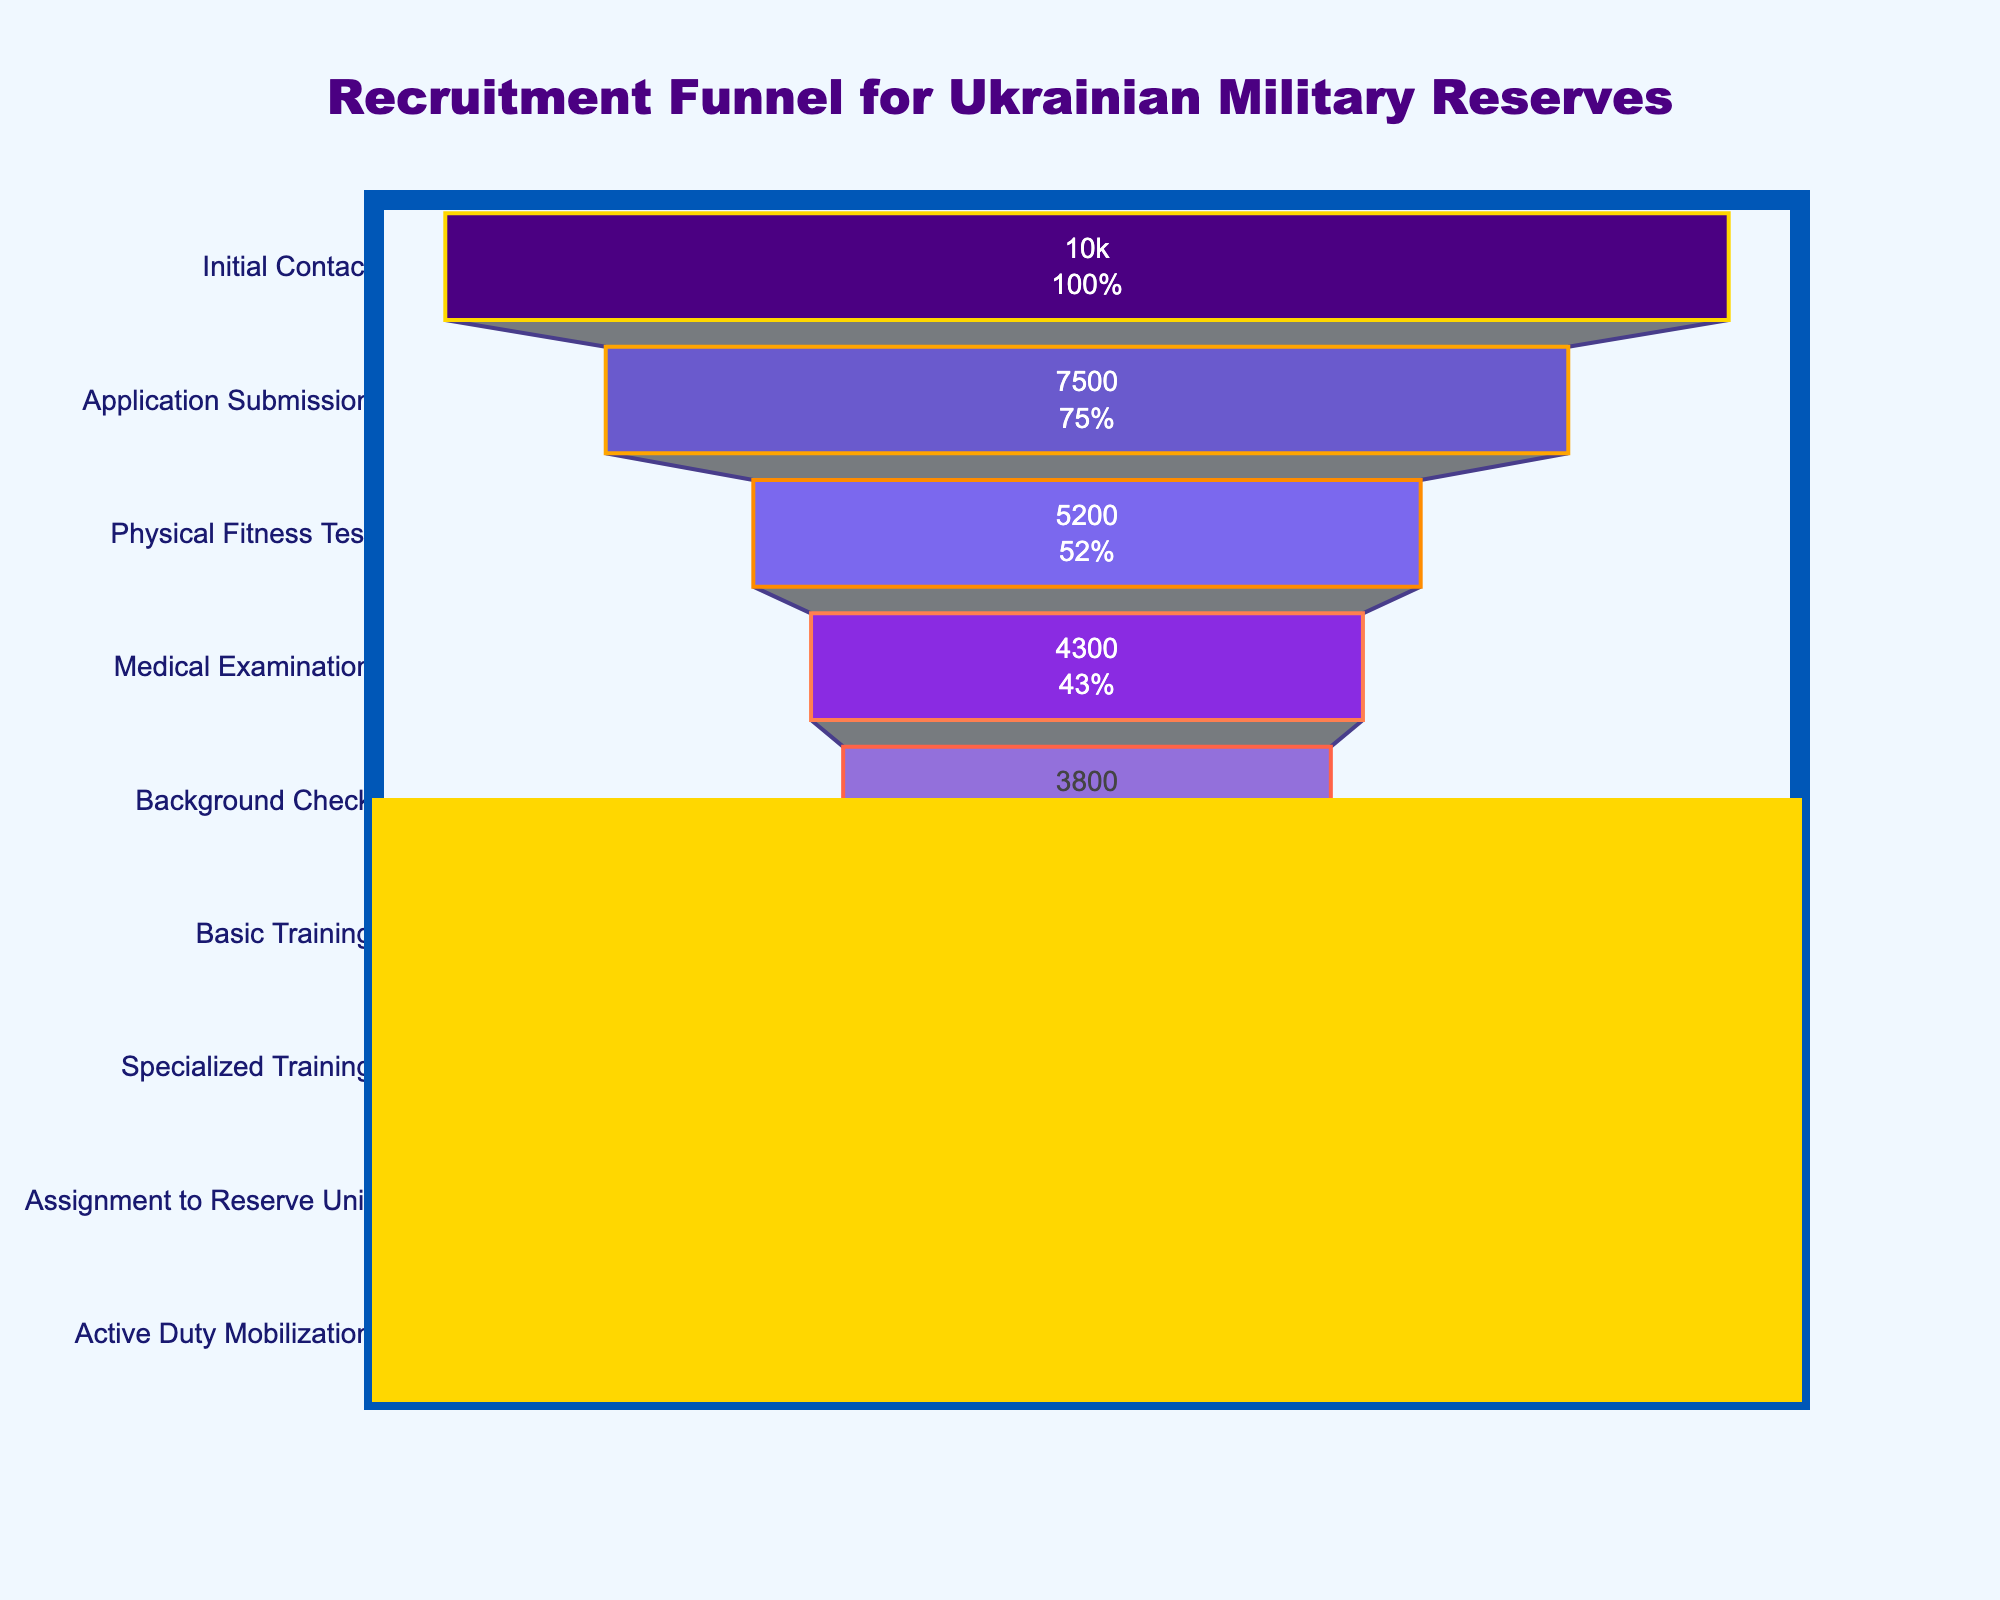How many stages are represented in the recruitment funnel? Count the unique stages listed on the y-axis of the funnel chart: Initial Contact, Application Submission, Physical Fitness Test, Medical Examination, Background Check, Basic Training, Specialized Training, Assignment to Reserve Unit, Active Duty Mobilization.
Answer: 9 Which stage has the highest number of candidates? The highest value on the x-axis represents the stage with the highest number of candidates. This is the Initial Contact stage with 10,000 candidates.
Answer: Initial Contact What is the percentage drop from Initial Contact to Active Duty Mobilization? To find the percentage drop, calculate the decrease in candidates: 10,000 (Initial Contact) - 1,800 (Active Duty Mobilization) = 8,200. Then divide by the initial number: 8,200 / 10,000 = 0.82. Convert to a percentage: 0.82 * 100 = 82%.
Answer: 82% How many candidates pass the Background Check stage? Look at the value on the x-axis that corresponds to the Background Check stage. It shows 3,800 candidates.
Answer: 3,800 Which stage has the smallest decrease in the number of candidates from the previous stage? Compare the differences in candidate numbers between each consecutive stage: 
Initial Contact to Application Submission: 10,000 - 7,500 = 2,500
Application Submission to Physical Fitness Test: 7,500 - 5,200 = 2,300
Physical Fitness Test to Medical Examination: 5,200 - 4,300 = 900
Medical Examination to Background Check: 4,300 - 3,800 = 500
Background Check to Basic Training: 3,800 - 3,200 = 600
Basic Training to Specialized Training: 3,200 - 2,800 = 400
Specialized Training to Assignment to Reserve Unit: 2,800 - 2,500 = 300
Assignment to Reserve Unit to Active Duty Mobilization: 2,500 - 1,800 = 700
The smallest decrease is from Specialized Training to Assignment to Reserve Unit, with a drop of 300 candidates.
Answer: Specialized Training to Assignment to Reserve Unit What proportion of candidates proceed from Application Submission to Physical Fitness Test? Calculate the proportion by dividing the number of candidates in the Physical Fitness Test stage by those in the Application Submission stage: 5,200 / 7,500 ≈ 0.6933. Convert to a percentage: 0.6933 * 100 ≈ 69.33%.
Answer: 69.33% How many candidates are lost between the Background Check and the Active Duty Mobilization stages? Subtract the number of candidates in the Active Duty Mobilization stage from those in the Background Check stage: 3,800 - 1,800 = 2,000 candidates lost.
Answer: 2,000 What is the average number of candidates across all stages? Sum the candidates at each stage and divide by the number of stages:
(10,000 + 7,500 + 5,200 + 4,300 + 3,800 + 3,200 + 2,800 + 2,500 + 1,800) / 9 = 41,100 / 9 ≈ 4,566.67 candidates.
Answer: 4,566.67 